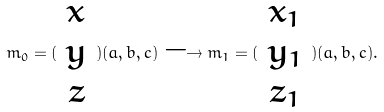Convert formula to latex. <formula><loc_0><loc_0><loc_500><loc_500>m _ { 0 } = ( \begin{array} { c } x \\ y \\ z \end{array} ) ( a , b , c ) \longrightarrow m _ { 1 } = ( \begin{array} { c } x _ { 1 } \\ y _ { 1 } \\ z _ { 1 } \end{array} ) ( a , b , c ) .</formula> 